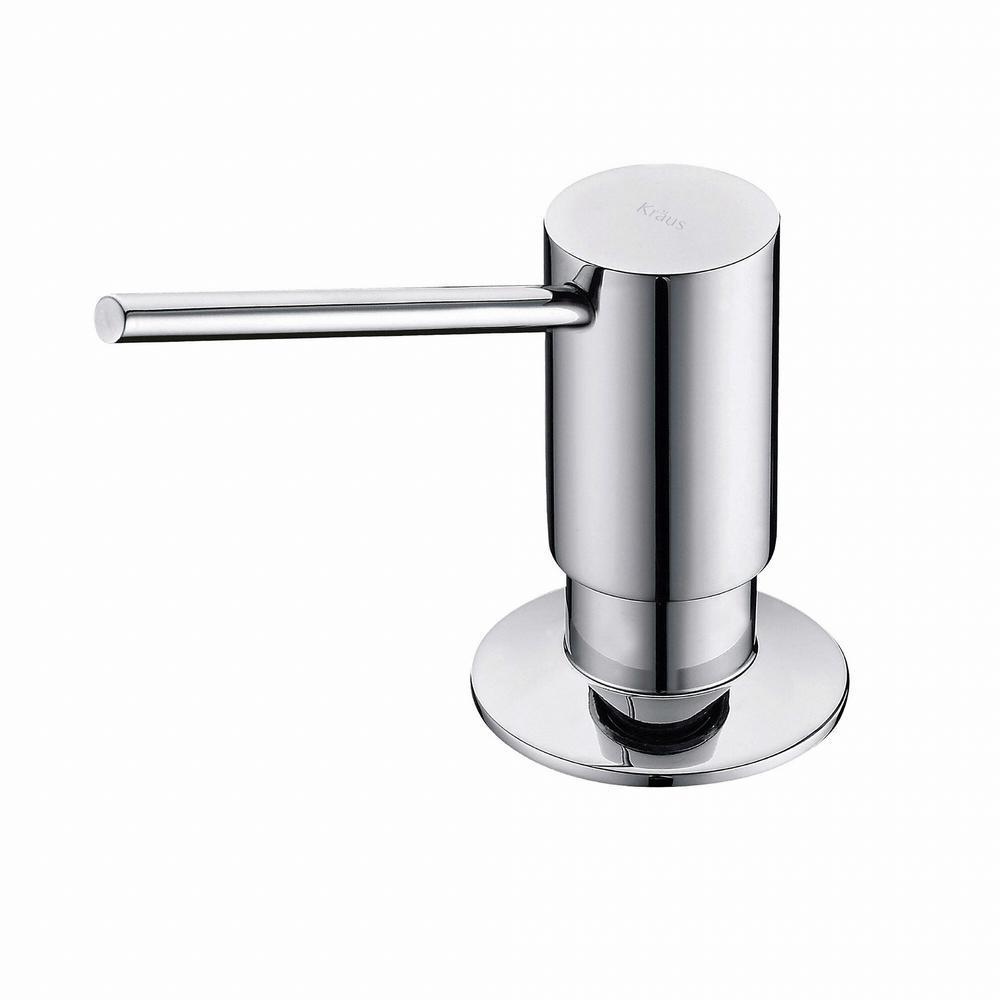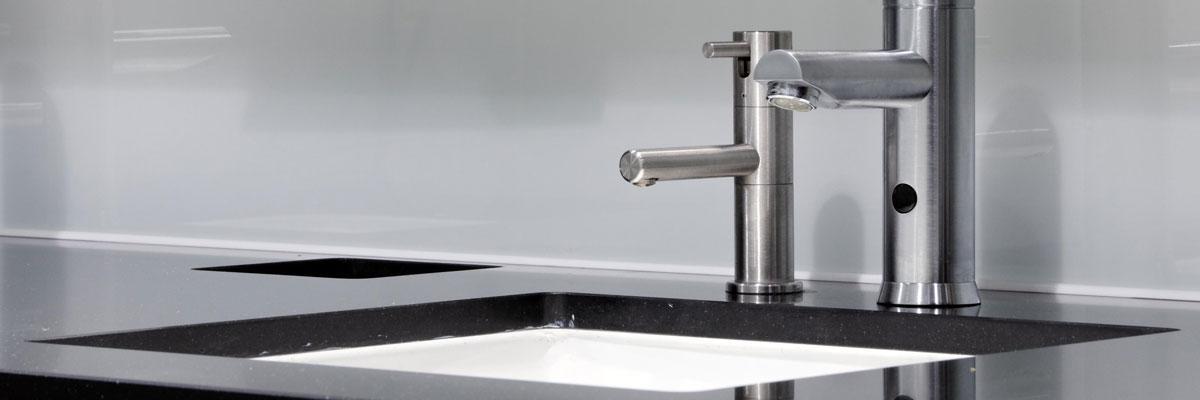The first image is the image on the left, the second image is the image on the right. Assess this claim about the two images: "At least one image includes a chrome-finish dispenser.". Correct or not? Answer yes or no. Yes. 